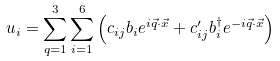Convert formula to latex. <formula><loc_0><loc_0><loc_500><loc_500>u _ { i } = \sum _ { q = 1 } ^ { 3 } \sum _ { i = 1 } ^ { 6 } \left ( c _ { i j } b _ { i } e ^ { i \vec { q } \cdot \vec { x } } + c ^ { \prime } _ { i j } b ^ { \dagger } _ { i } e ^ { - i \vec { q } \cdot \vec { x } } \right )</formula> 